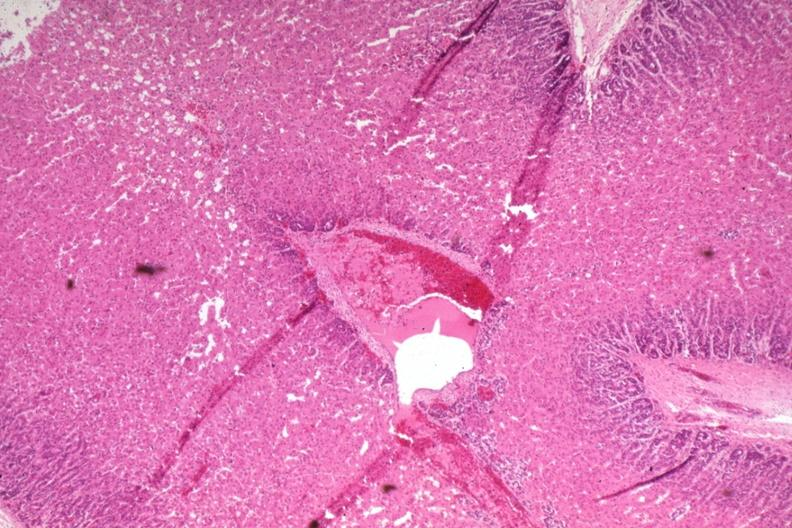s adrenal present?
Answer the question using a single word or phrase. Yes 